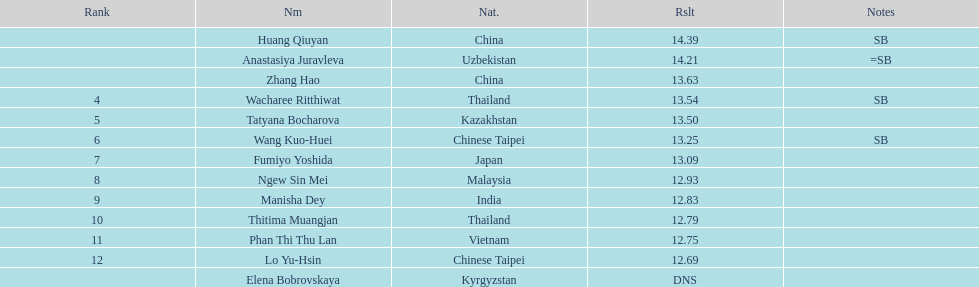How many competitors had less than 13.00 points? 6. 